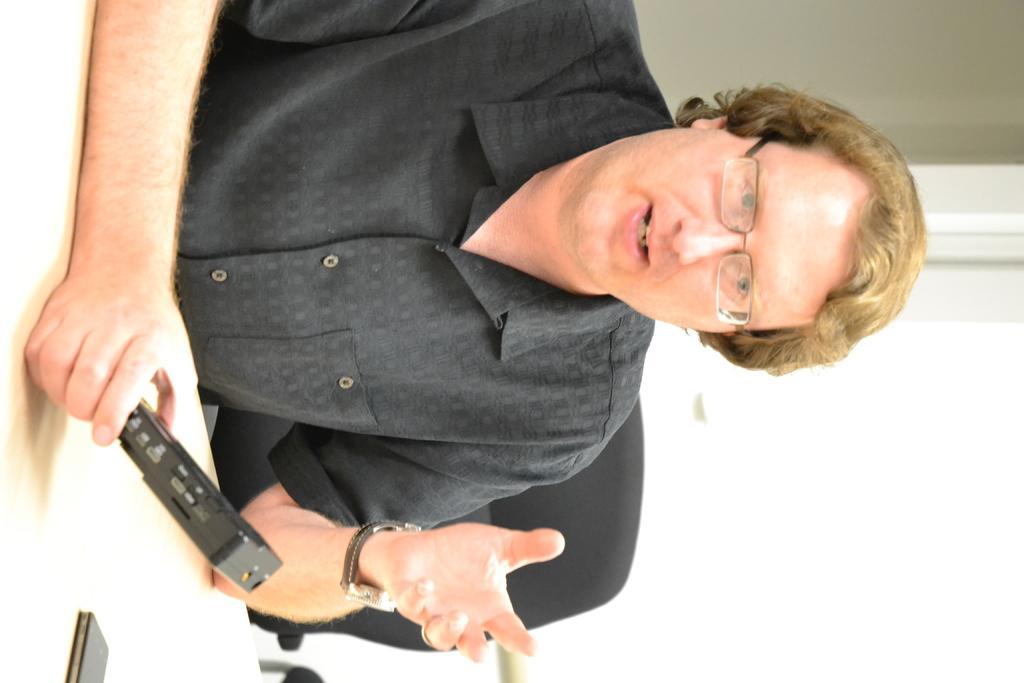Describe this image in one or two sentences. In this picture we can see a man is sitting on a chair and the man is holding an object. In front of the man there is a table and behind the man there is a wall. 